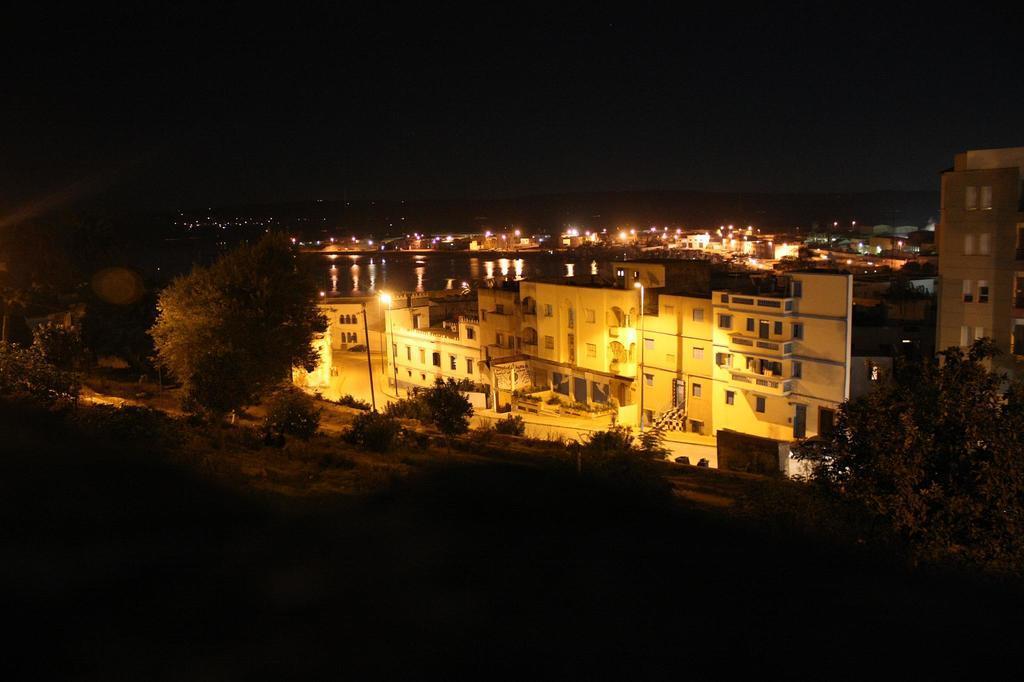Can you describe this image briefly? This picture shows few buildings and we see lighting and trees and we see few plants and few pole lights. 